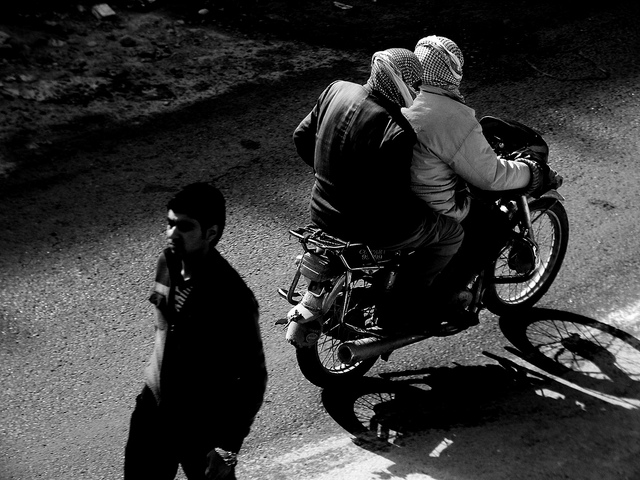How many people are on the motorcycle? 2 